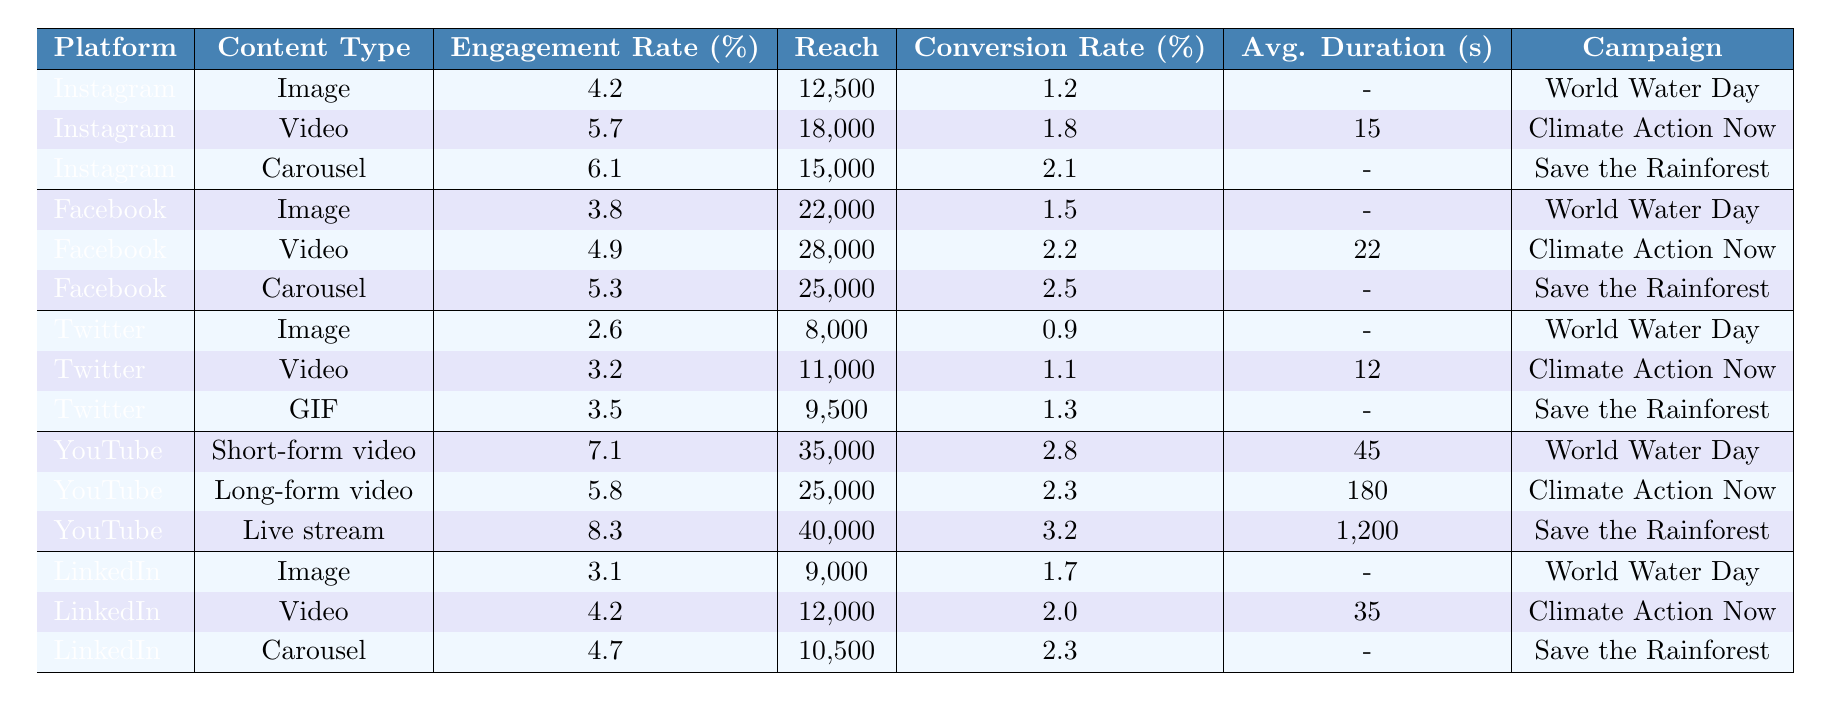What's the highest engagement rate among the platforms? By looking at the engagement rate column, the highest value is 8.3, which corresponds to the YouTube Live stream content type.
Answer: 8.3 Which platform has the highest reach for video content? Checking the reach for video content types, Facebook has the highest reach of 28,000.
Answer: Facebook What is the average engagement rate for Instagram posts? The engagement rates for Instagram are 4.2, 5.7, and 6.1. Summing them gives 4.2 + 5.7 + 6.1 = 16. The average is 16/3 = 5.33.
Answer: 5.33 Is the conversion rate for the YouTube Short-form video higher than the Carousel posts on Facebook? The conversion rate for YouTube Short-form video is 2.8, while for Facebook Carousel posts it's 2.5. Since 2.8 > 2.5, the statement is true.
Answer: Yes Which content type has the lowest engagement rate on Twitter? The engagement rates for Twitter are 2.6 for Image, 3.2 for Video, and 3.5 for GIF. The lowest is 2.6 for Image content type.
Answer: Image What is the total reach for all YouTube content types? For YouTube, the reach values are 35,000, 25,000, and 40,000. Summing them: 35,000 + 25,000 + 40,000 = 100,000.
Answer: 100,000 What is the difference in conversion rates between the highest and lowest conversion rates on Instagram? The conversion rates for Instagram are 1.2, 1.8, and 2.1. The lowest is 1.2 and the highest is 2.1. The difference is 2.1 - 1.2 = 0.9.
Answer: 0.9 Is there any content type on LinkedIn with an engagement rate below 4%? The engagement rates for LinkedIn are 3.1 for Image, 4.2 for Video, and 4.7 for Carousel. Since 3.1 < 4, the answer is Yes.
Answer: Yes Which campaign had the highest reach across all platforms? Among all campaigns, the maximum reach is 40,000 for the YouTube Live stream for "Save the Rainforest."
Answer: Save the Rainforest What is the average duration of videos on Facebook? The average duration for Facebook videos is 22 seconds for one video but not applicable for others as they have null values. Hence, that's the only consideration here.
Answer: 22 seconds 